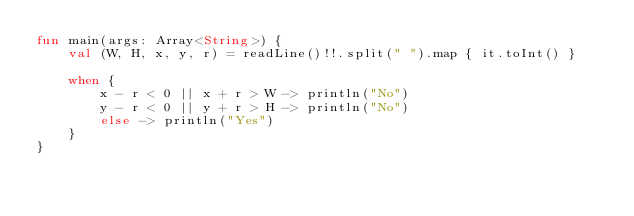<code> <loc_0><loc_0><loc_500><loc_500><_Kotlin_>fun main(args: Array<String>) {
    val (W, H, x, y, r) = readLine()!!.split(" ").map { it.toInt() }
    
    when {
        x - r < 0 || x + r > W -> println("No")
        y - r < 0 || y + r > H -> println("No")
        else -> println("Yes")
    }
}

</code> 